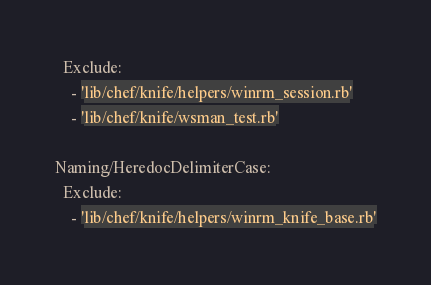Convert code to text. <code><loc_0><loc_0><loc_500><loc_500><_YAML_>  Exclude:
    - 'lib/chef/knife/helpers/winrm_session.rb'
    - 'lib/chef/knife/wsman_test.rb'

Naming/HeredocDelimiterCase:
  Exclude:
    - 'lib/chef/knife/helpers/winrm_knife_base.rb'
</code> 